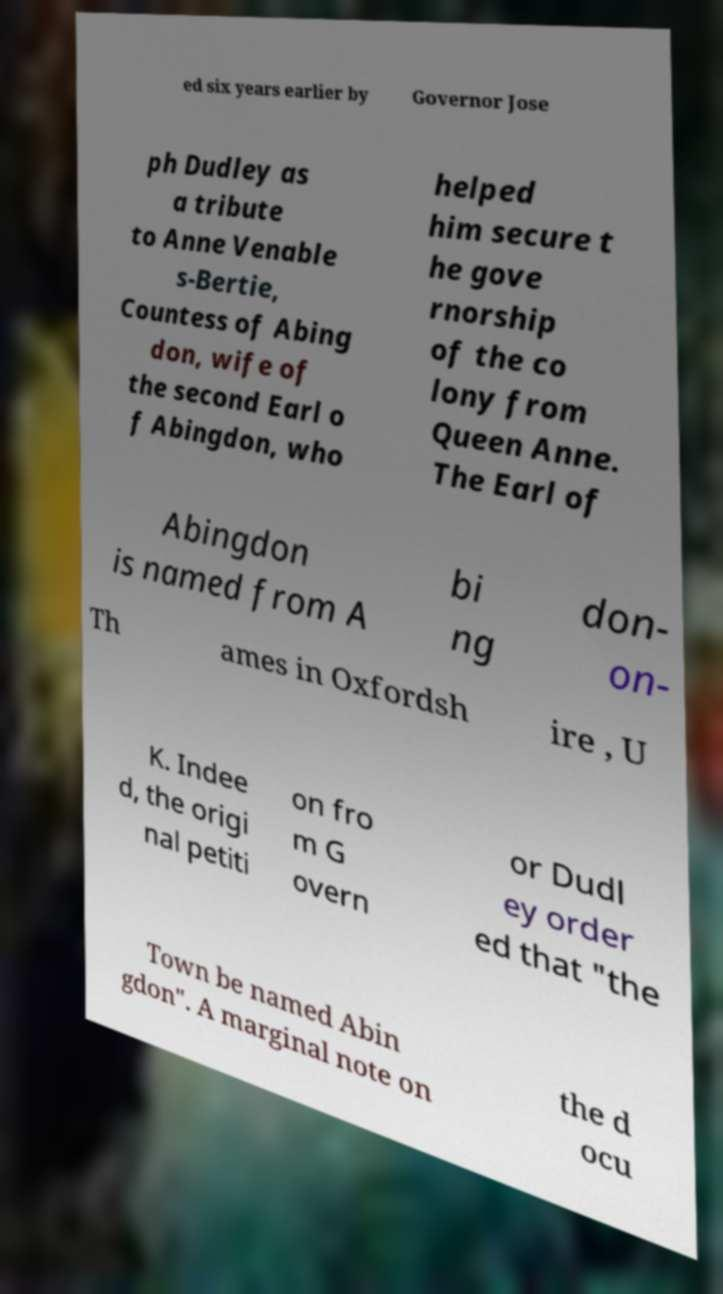For documentation purposes, I need the text within this image transcribed. Could you provide that? ed six years earlier by Governor Jose ph Dudley as a tribute to Anne Venable s-Bertie, Countess of Abing don, wife of the second Earl o f Abingdon, who helped him secure t he gove rnorship of the co lony from Queen Anne. The Earl of Abingdon is named from A bi ng don- on- Th ames in Oxfordsh ire , U K. Indee d, the origi nal petiti on fro m G overn or Dudl ey order ed that "the Town be named Abin gdon". A marginal note on the d ocu 